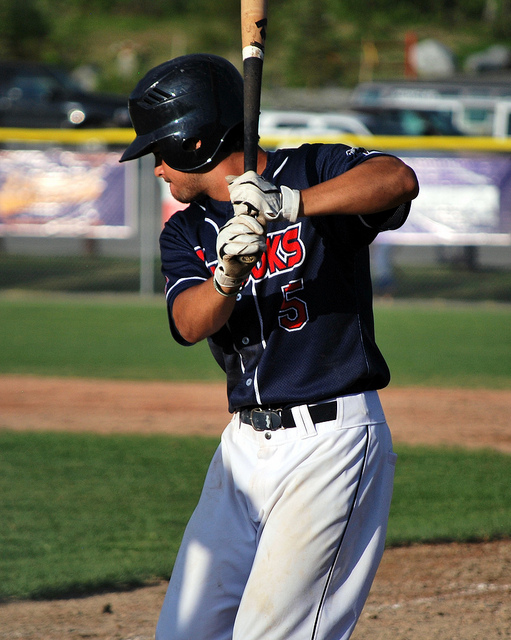Extract all visible text content from this image. 5 3 